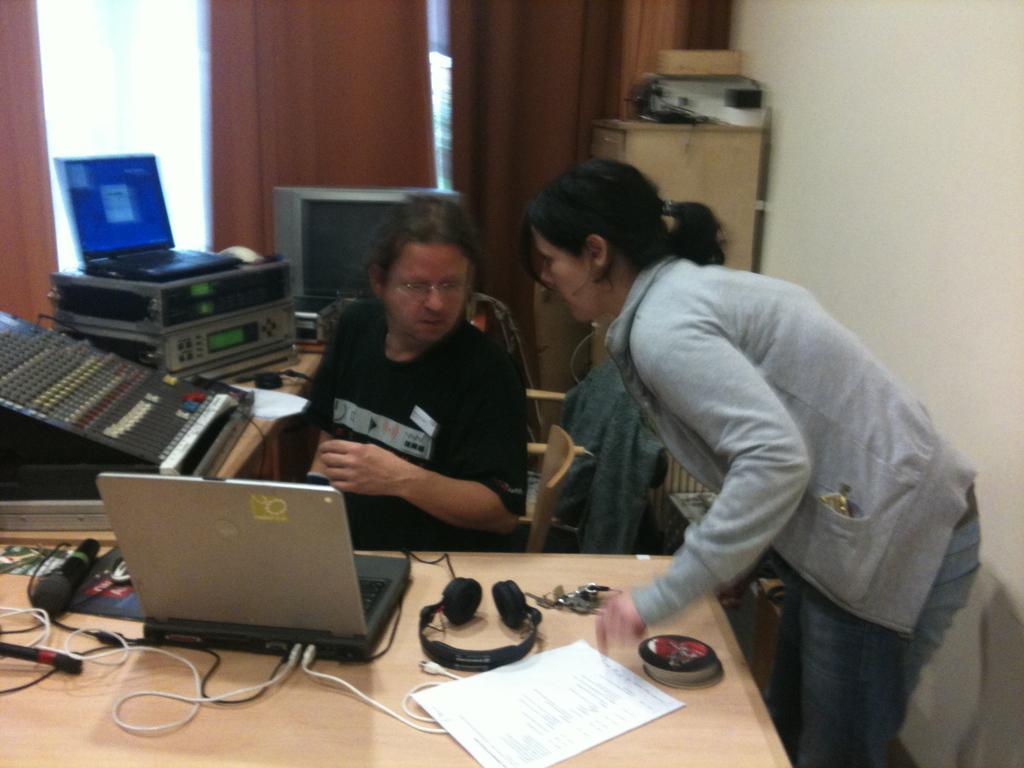How would you summarize this image in a sentence or two? This person sitting on the chair and this standing. In front of this person we can see tables on the table we can see laptop,microphone,headset,keys,paper,cables and electrical objects. On the table we can see wall,curtain,glass window. 